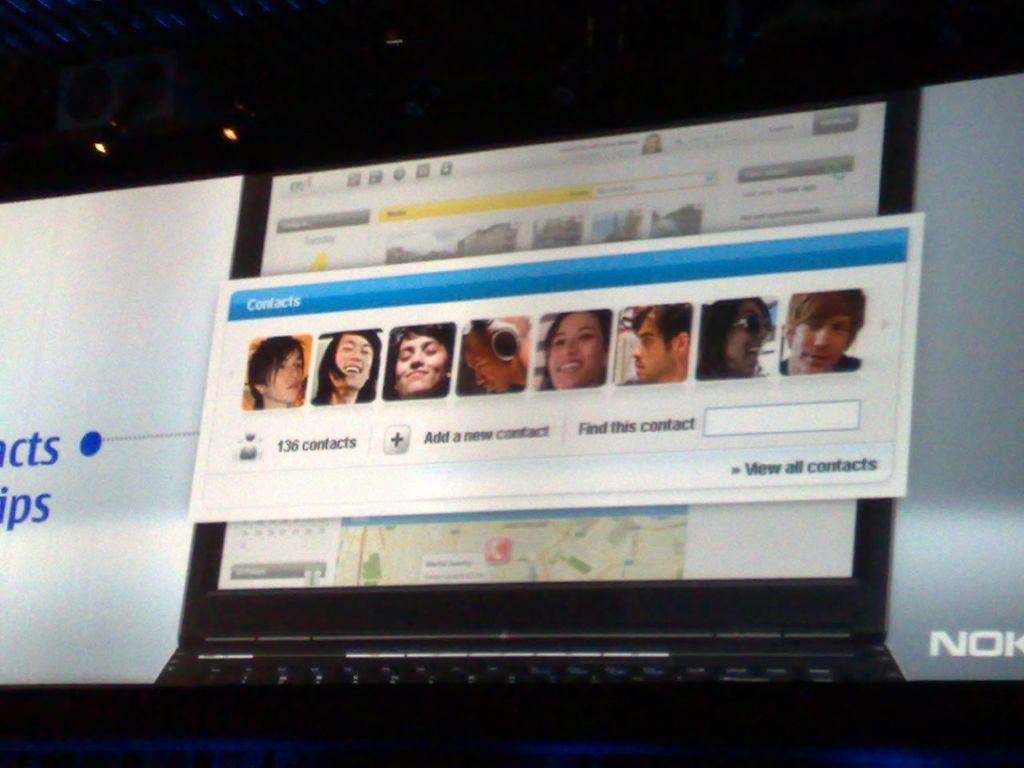<image>
Describe the image concisely. a lap top computer screen with someone's contact list open and several pictues being displayed. 